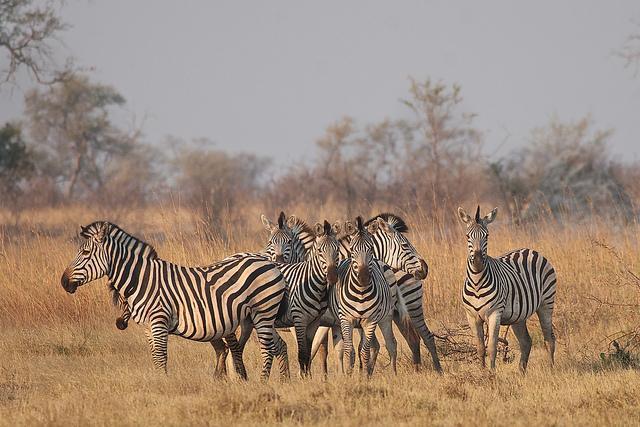How many zebras are there?
Give a very brief answer. 7. How many are facing the camera?
Give a very brief answer. 4. How many kinds of animals are clearly visible?
Give a very brief answer. 1. How many zebras are facing the camera?
Give a very brief answer. 4. How many sinks are there?
Give a very brief answer. 0. 